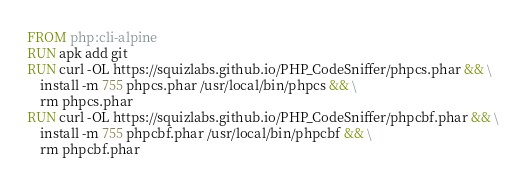<code> <loc_0><loc_0><loc_500><loc_500><_Dockerfile_>FROM php:cli-alpine
RUN apk add git
RUN curl -OL https://squizlabs.github.io/PHP_CodeSniffer/phpcs.phar && \
    install -m 755 phpcs.phar /usr/local/bin/phpcs && \
    rm phpcs.phar
RUN curl -OL https://squizlabs.github.io/PHP_CodeSniffer/phpcbf.phar && \
    install -m 755 phpcbf.phar /usr/local/bin/phpcbf && \
    rm phpcbf.phar</code> 